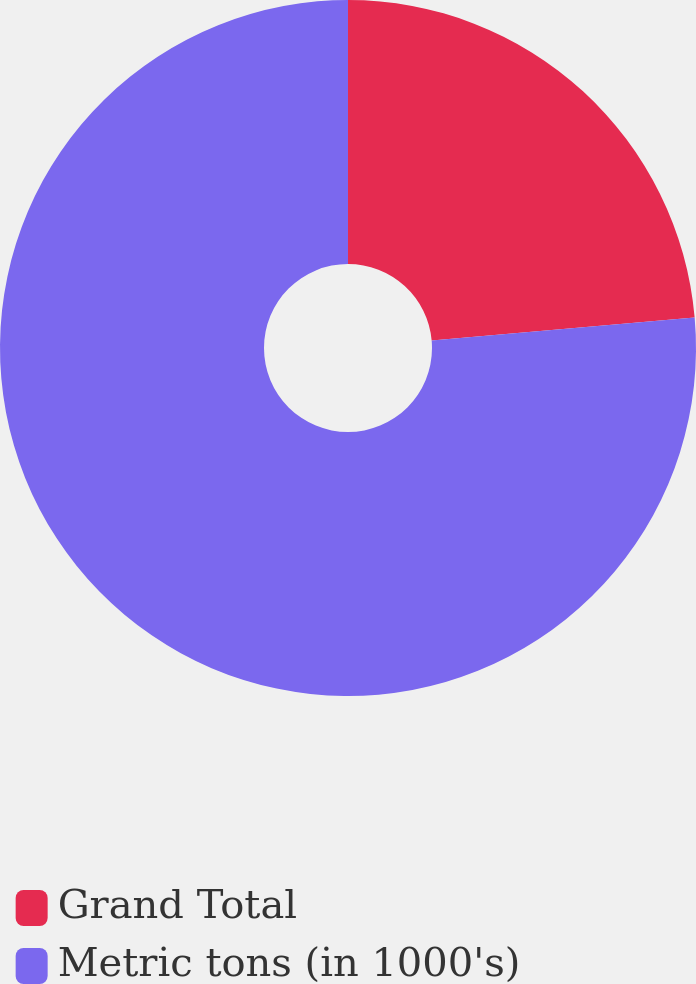<chart> <loc_0><loc_0><loc_500><loc_500><pie_chart><fcel>Grand Total<fcel>Metric tons (in 1000's)<nl><fcel>23.6%<fcel>76.4%<nl></chart> 